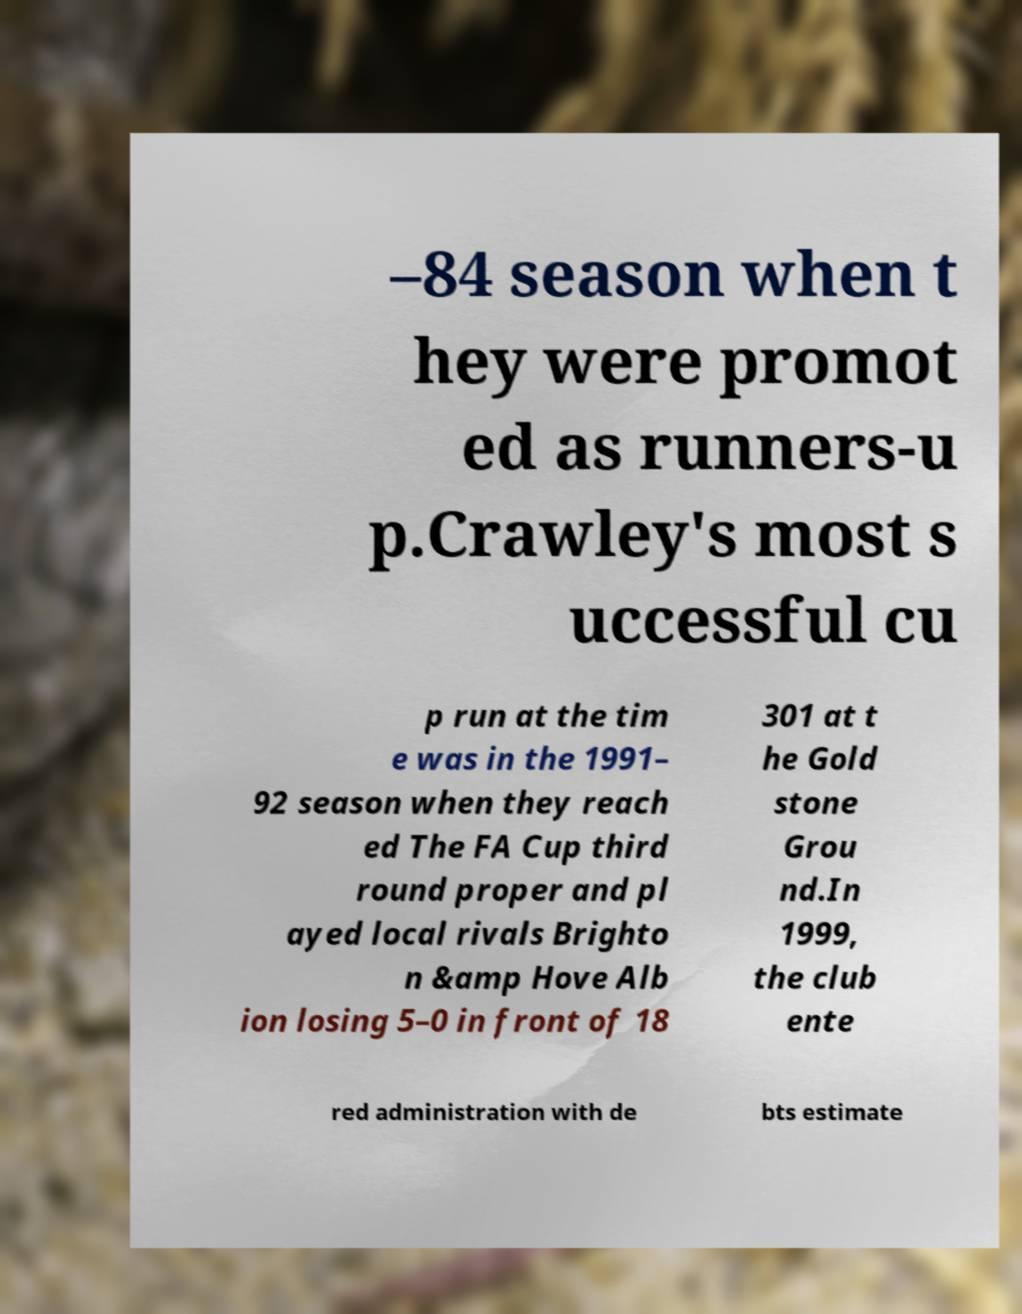Please identify and transcribe the text found in this image. –84 season when t hey were promot ed as runners-u p.Crawley's most s uccessful cu p run at the tim e was in the 1991– 92 season when they reach ed The FA Cup third round proper and pl ayed local rivals Brighto n &amp Hove Alb ion losing 5–0 in front of 18 301 at t he Gold stone Grou nd.In 1999, the club ente red administration with de bts estimate 